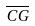<formula> <loc_0><loc_0><loc_500><loc_500>\overline { C G }</formula> 